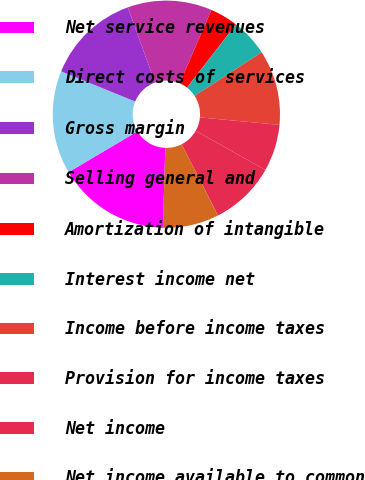Convert chart to OTSL. <chart><loc_0><loc_0><loc_500><loc_500><pie_chart><fcel>Net service revenues<fcel>Direct costs of services<fcel>Gross margin<fcel>Selling general and<fcel>Amortization of intangible<fcel>Interest income net<fcel>Income before income taxes<fcel>Provision for income taxes<fcel>Net income<fcel>Net income available to common<nl><fcel>16.0%<fcel>14.67%<fcel>13.33%<fcel>12.0%<fcel>4.0%<fcel>5.33%<fcel>10.67%<fcel>6.67%<fcel>9.33%<fcel>8.0%<nl></chart> 